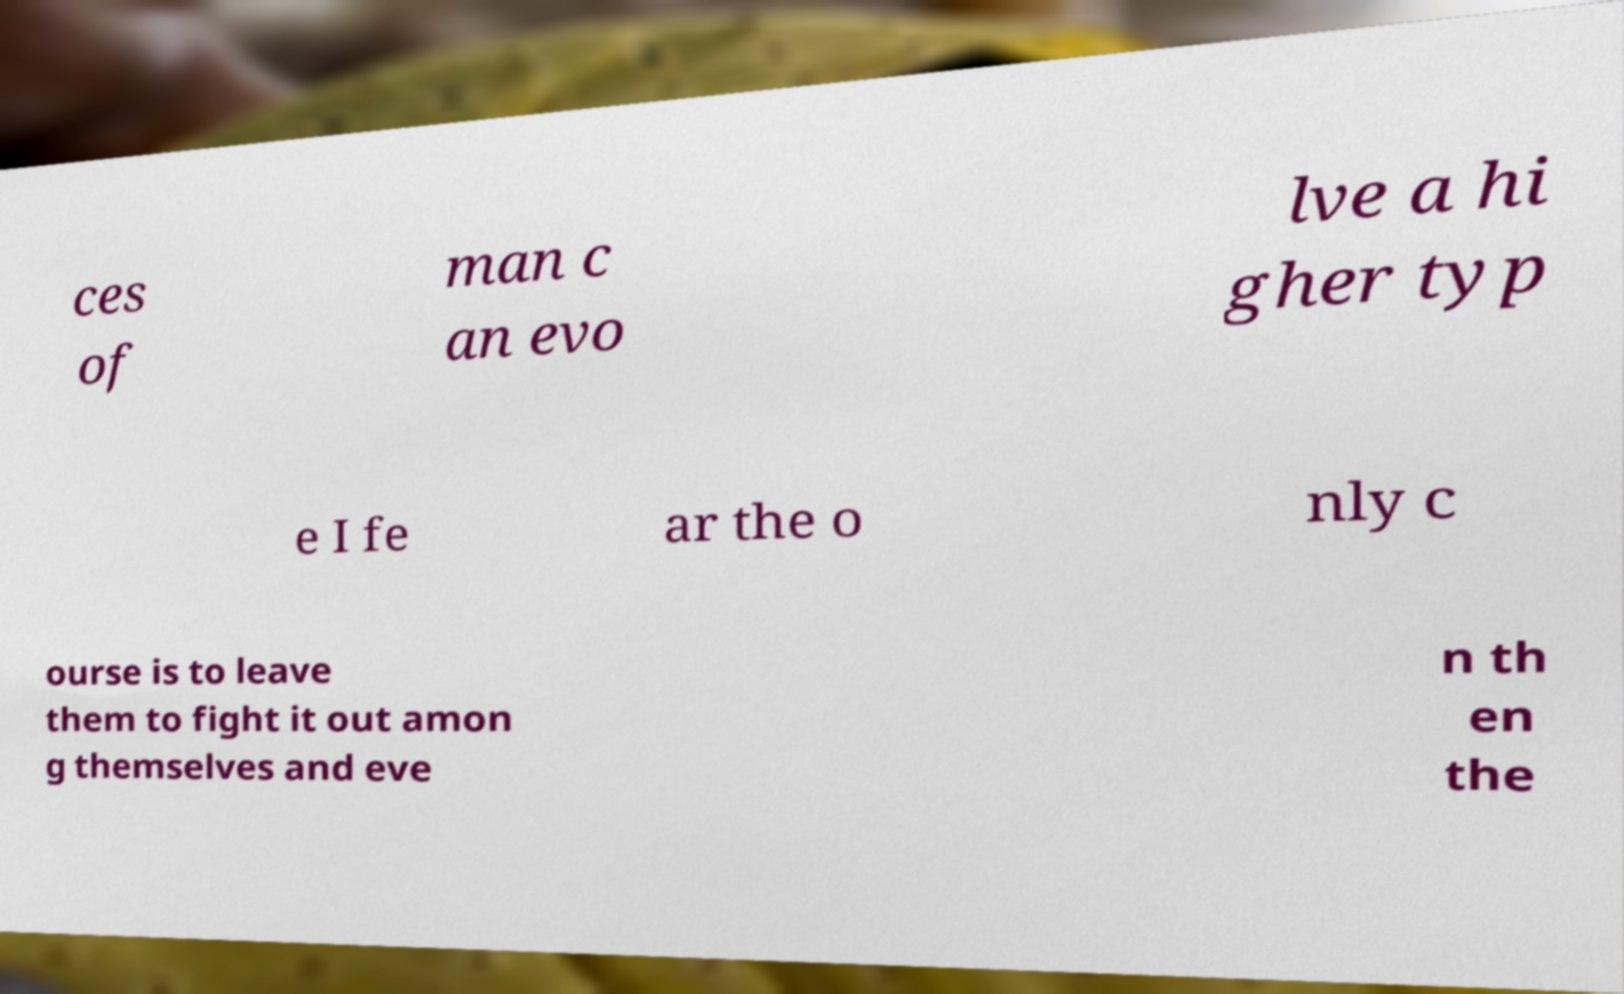Could you assist in decoding the text presented in this image and type it out clearly? ces of man c an evo lve a hi gher typ e I fe ar the o nly c ourse is to leave them to fight it out amon g themselves and eve n th en the 